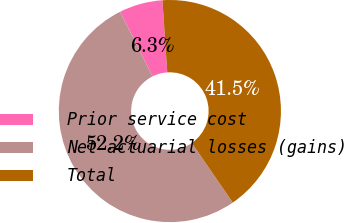Convert chart to OTSL. <chart><loc_0><loc_0><loc_500><loc_500><pie_chart><fcel>Prior service cost<fcel>Net actuarial losses (gains)<fcel>Total<nl><fcel>6.33%<fcel>52.18%<fcel>41.49%<nl></chart> 